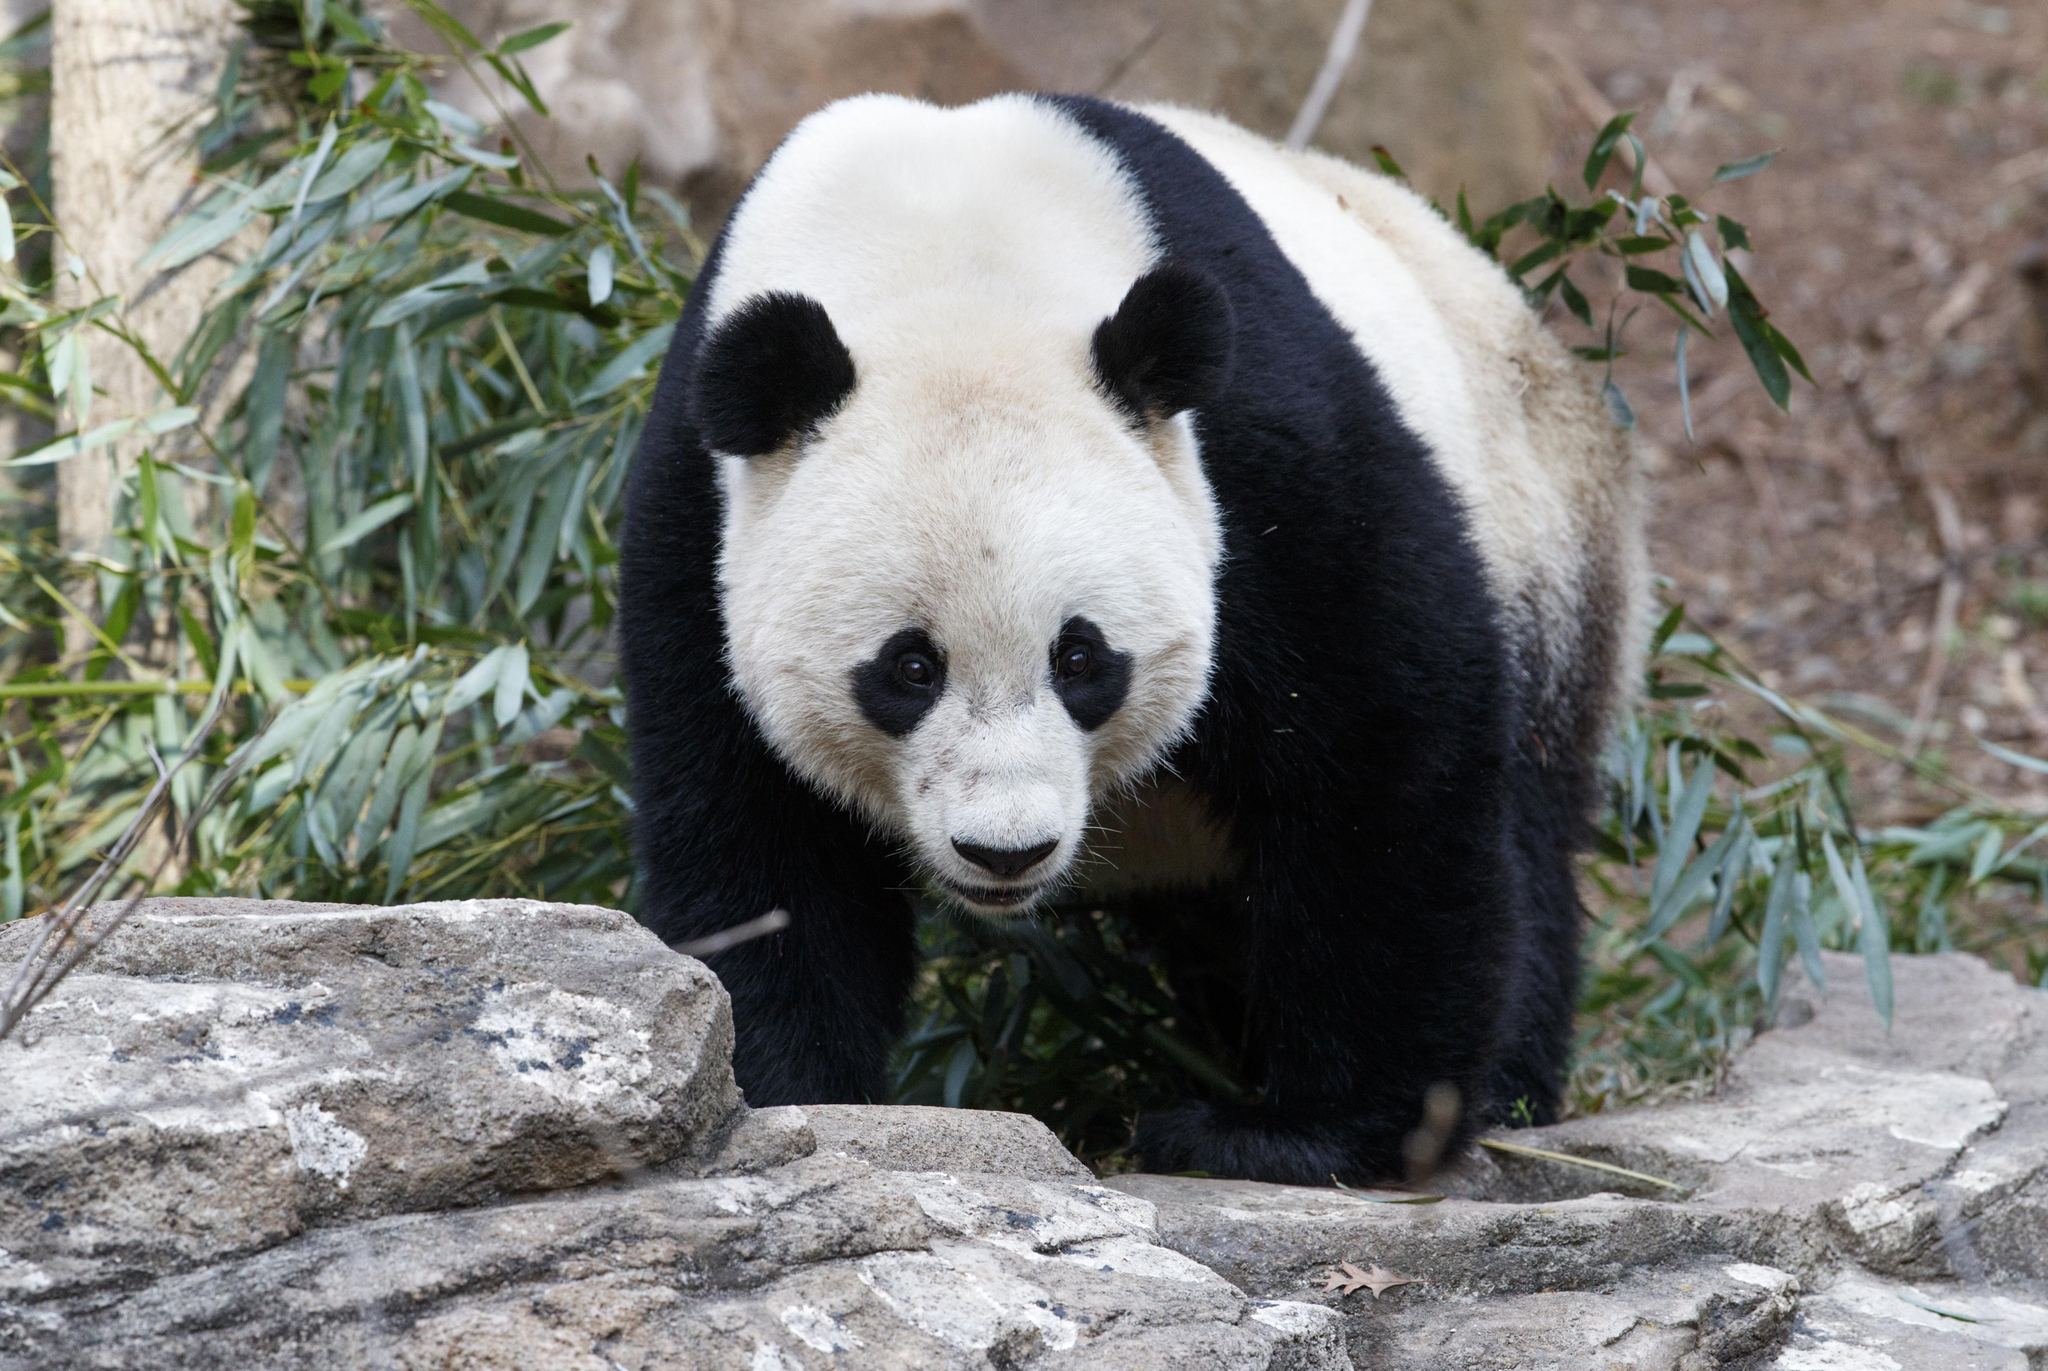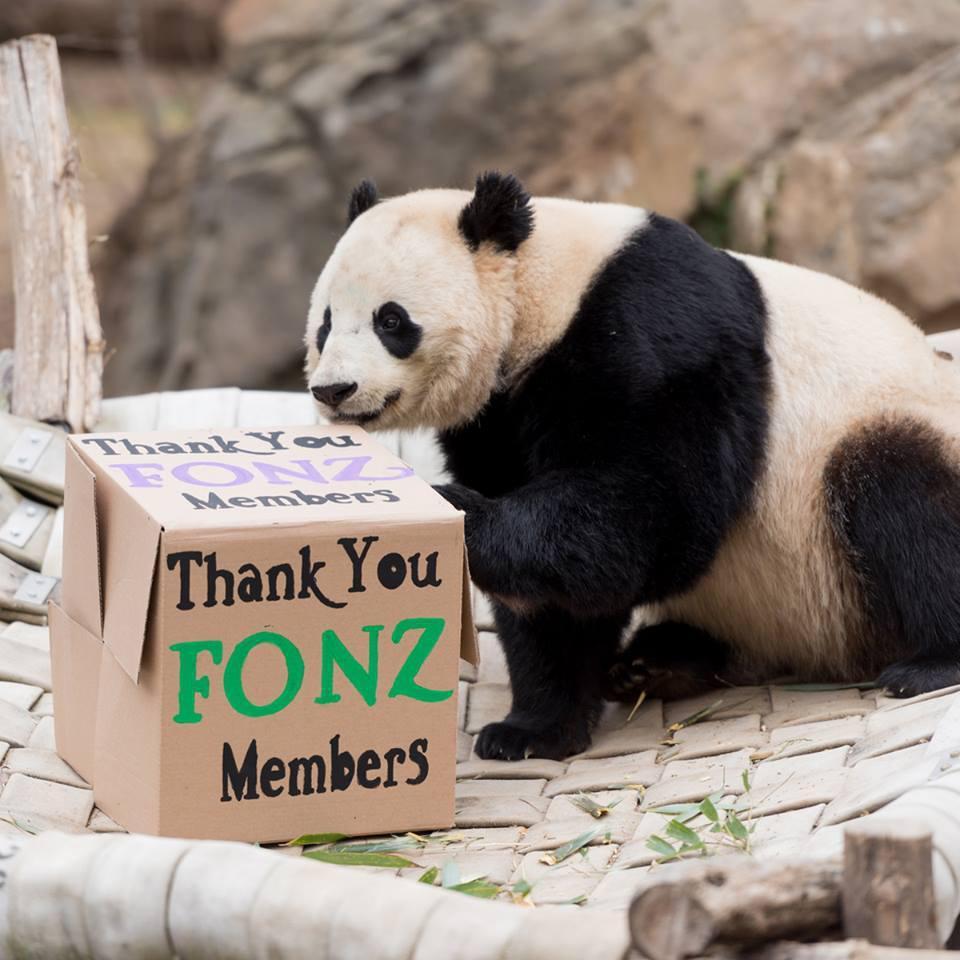The first image is the image on the left, the second image is the image on the right. For the images shown, is this caption "Each image contains a single panda, and one image shows a panda reaching one paw toward a manmade object with a squarish base." true? Answer yes or no. Yes. 